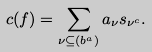<formula> <loc_0><loc_0><loc_500><loc_500>c ( f ) = \sum _ { \nu \subseteq ( b ^ { a } ) } a _ { \nu } s _ { \nu ^ { c } } .</formula> 